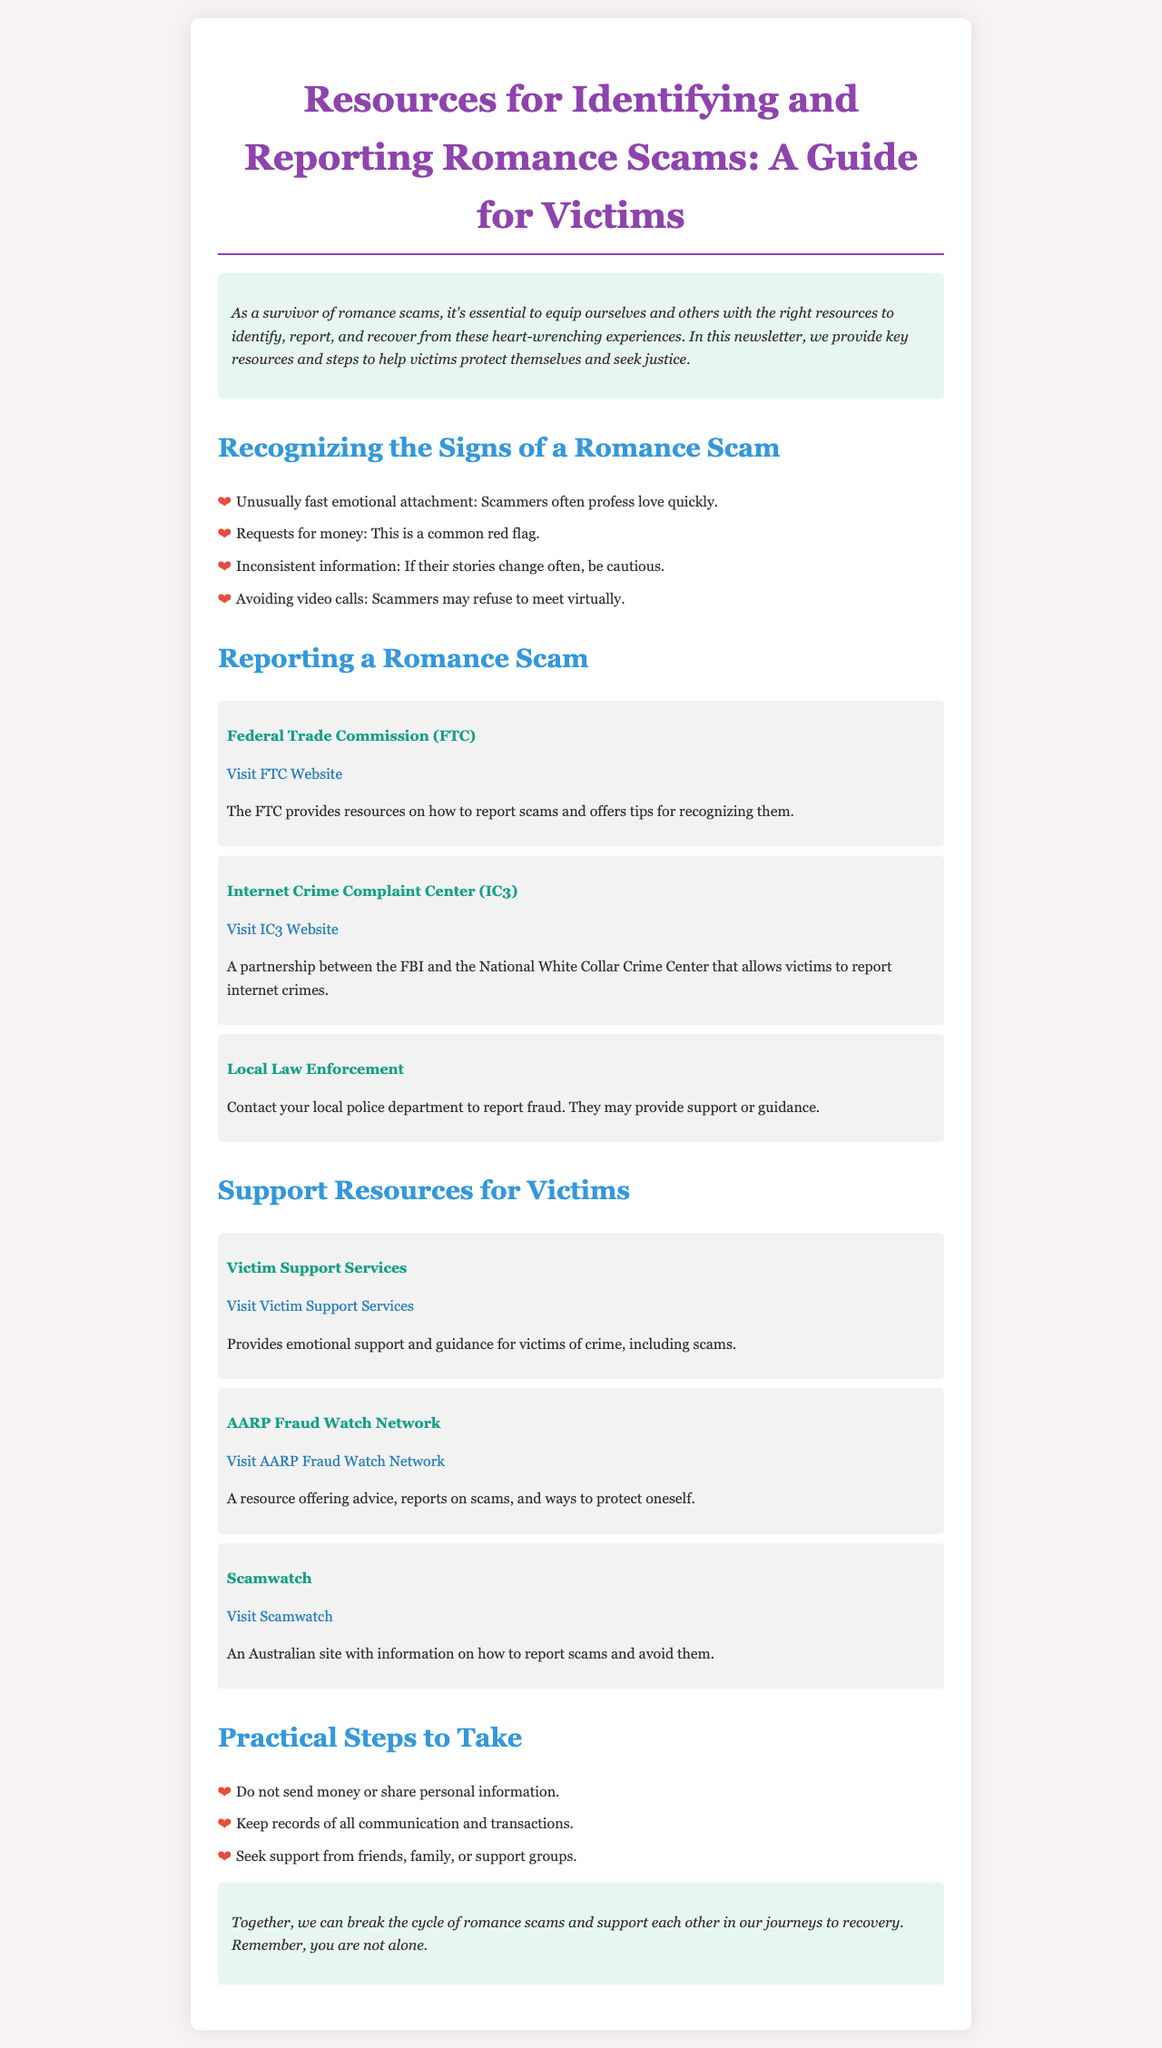what is the title of the newsletter? The title is provided at the top of the document, outlining the main focus and purpose of the content.
Answer: Resources for Identifying and Reporting Romance Scams: A Guide for Victims which organization provides tips for recognizing scams? This information is found in the reporting section, highlighting a key resource for victims.
Answer: Federal Trade Commission (FTC) how many signs of a romance scam are listed? The document outlines specific signs in the "Recognizing the Signs of a Romance Scam" section.
Answer: Four what is one practical step to take after being scammed? The document lists practical steps that victims can follow, emphasizing the importance of safeguarding personal information.
Answer: Do not send money or share personal information which website offers support and guidance for crime victims? This resource is mentioned in the support section, directing victims to seek help.
Answer: Victim Support Services 